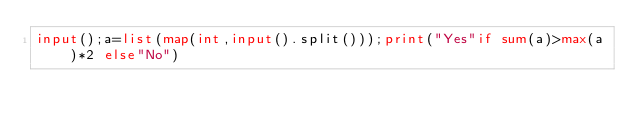Convert code to text. <code><loc_0><loc_0><loc_500><loc_500><_Python_>input();a=list(map(int,input().split()));print("Yes"if sum(a)>max(a)*2 else"No")</code> 